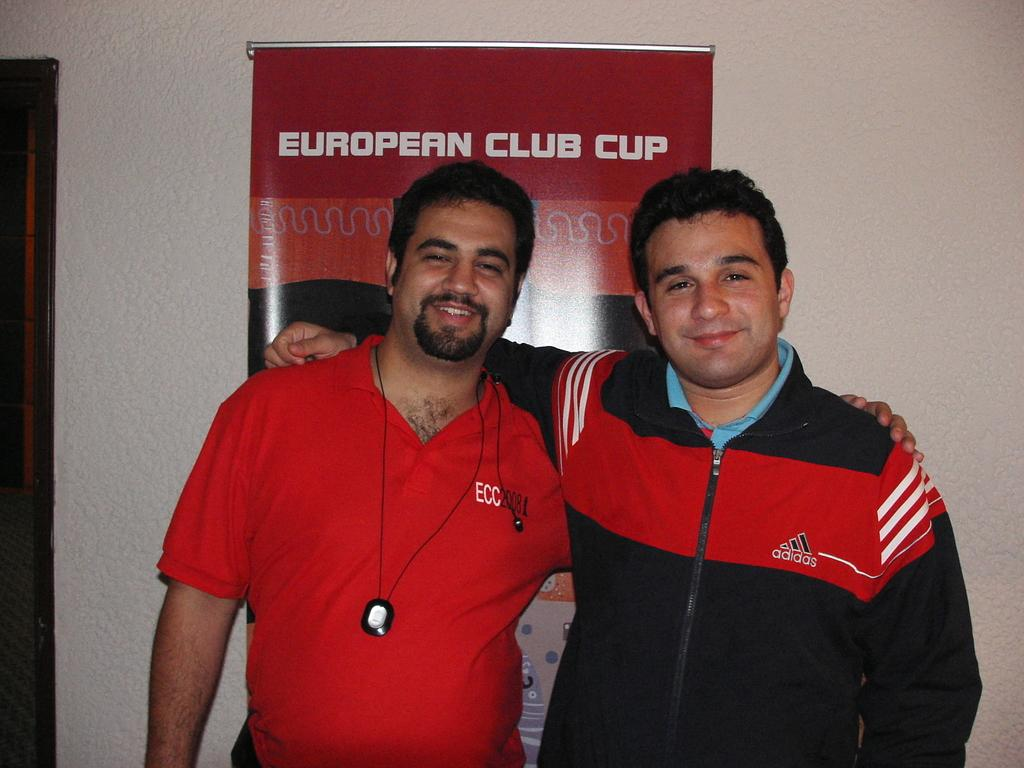<image>
Offer a succinct explanation of the picture presented. Two men wearing red and black stand in front of a European Club Cup poster. 